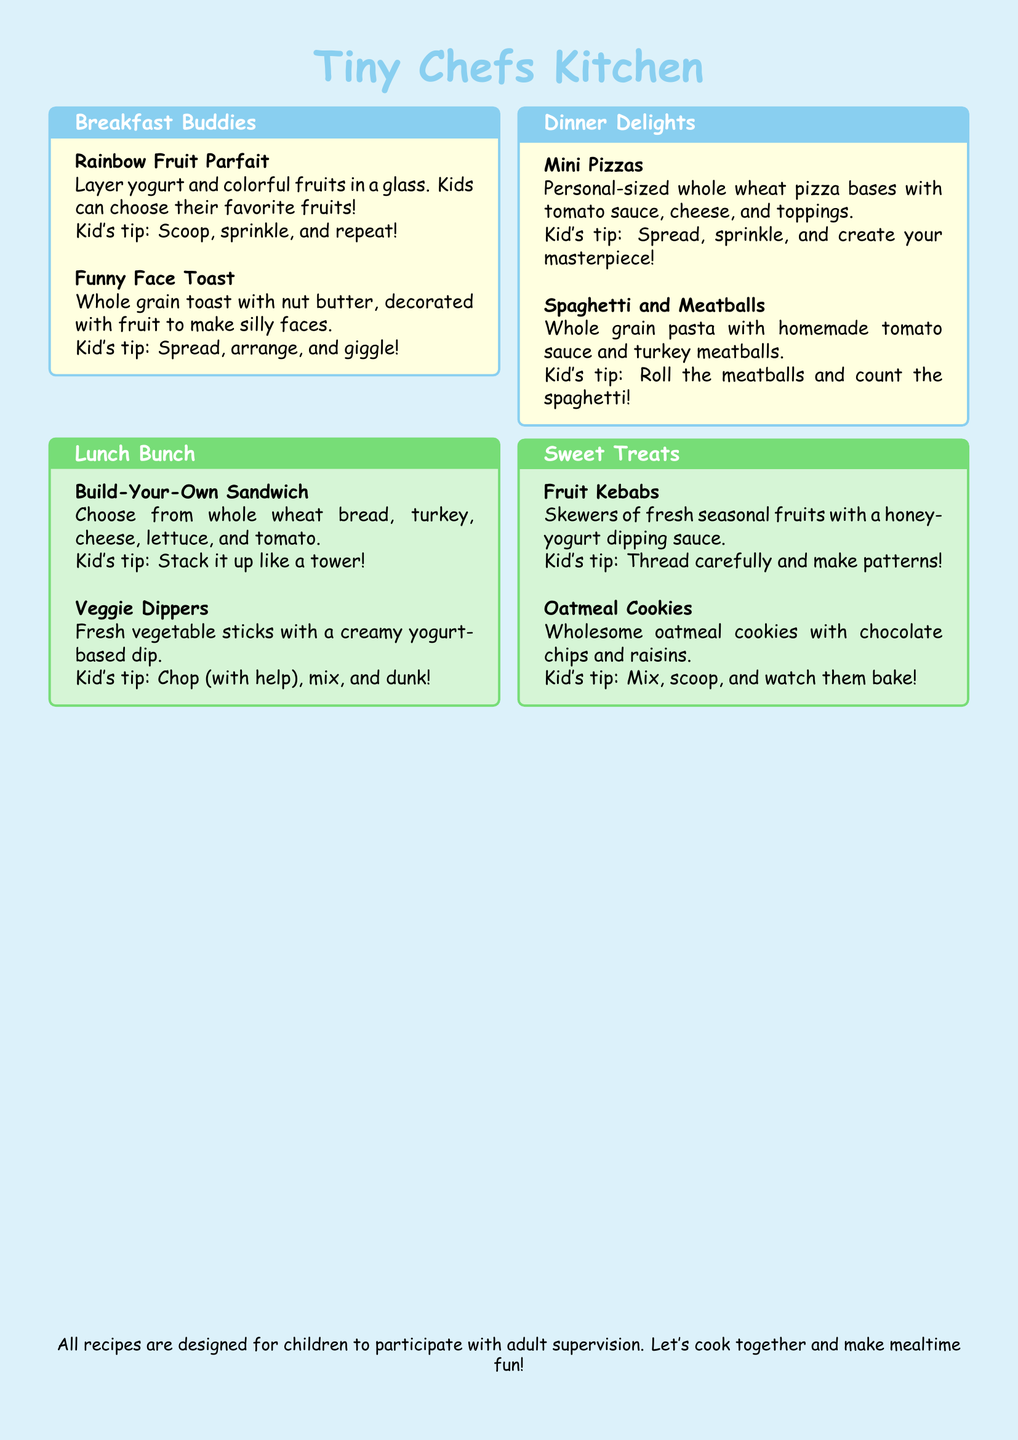What is the title of the menu? The title of the menu is presented prominently at the top of the document.
Answer: Tiny Chefs Kitchen How many sections are there in the menu? The menu is divided into four distinct sections for different meals.
Answer: Four What is the first item listed under Breakfast Buddies? The first item listed provides a specific recipe suitable for breakfast.
Answer: Rainbow Fruit Parfait What is a tip for the Mini Pizzas? The tip gives children a fun way to engage with the recipe.
Answer: Spread, sprinkle, and create your masterpiece! Which section contains Veggie Dippers? The section informs about the types of meals and their categorization.
Answer: Lunch Bunch How many recipes are included in the Sweet Treats section? The count of the recipes in this specific area is needed for clarity.
Answer: Two What type of cookies are mentioned in the Sweet Treats section? This specifies the food item and its characteristics.
Answer: Oatmeal Cookies What is emphasized for all recipes regarding children? The document instructs about the nature of participation while preparing meals.
Answer: Adult supervision 